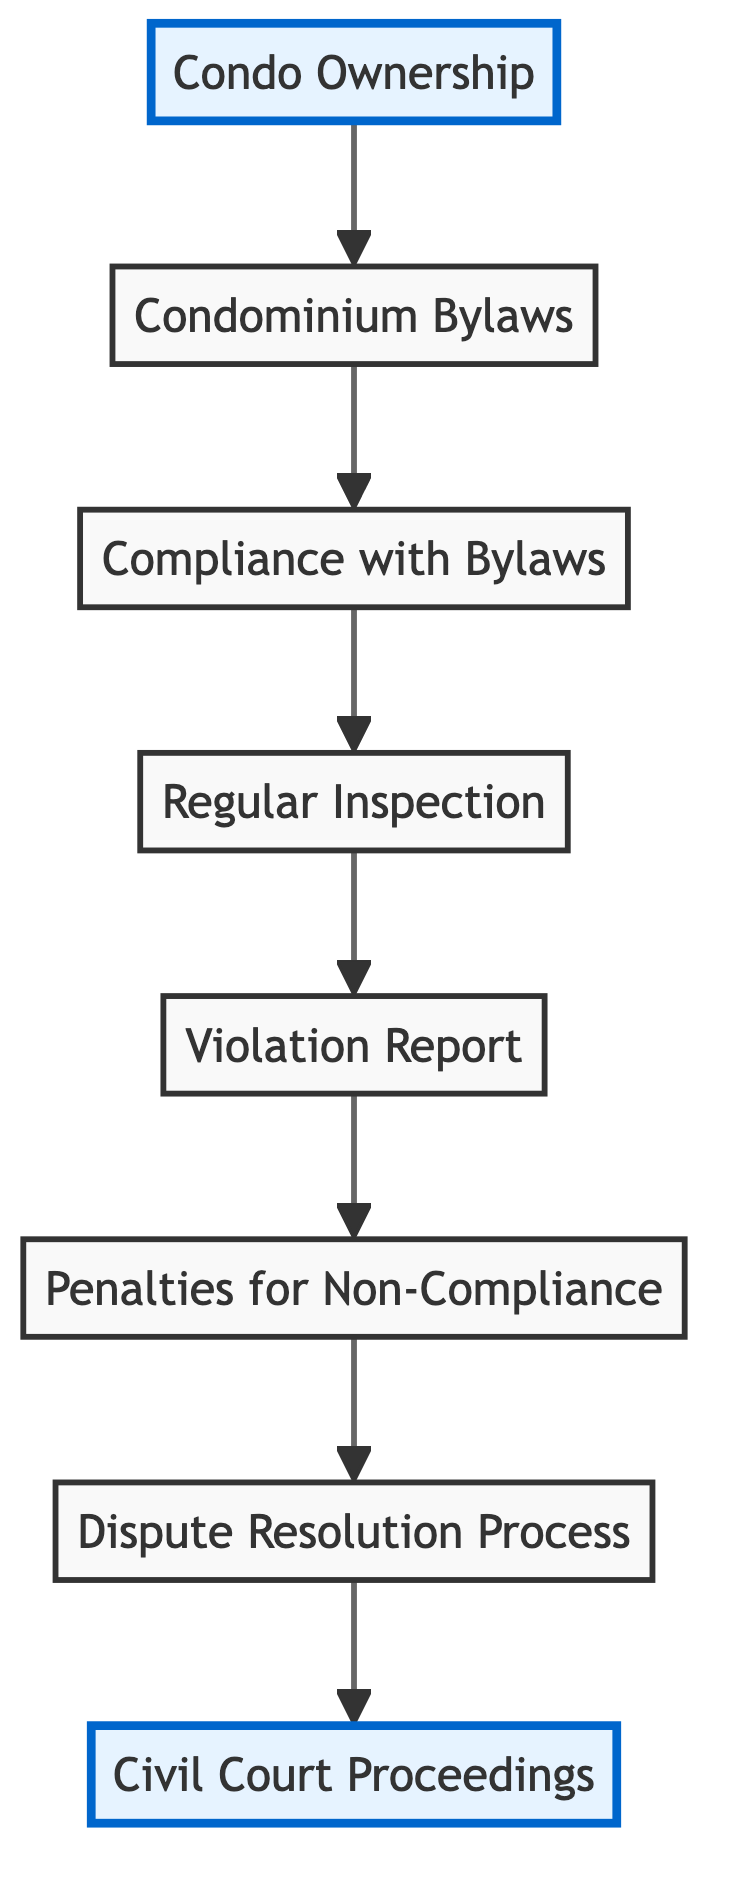What is the starting point of the responsibilities? The starting point of the responsibilities in the diagram is "Condo Ownership." This is the first node from which the flow of legal responsibilities begins.
Answer: Condo Ownership How many nodes are present in the diagram? The diagram contains 8 distinct nodes, which include "Condo Ownership," "Condominium Bylaws," "Compliance with Bylaws," "Regular Inspection," "Violation Report," "Penalties for Non-Compliance," "Dispute Resolution Process," and "Civil Court Proceedings." I counted each unique node in the visual representation.
Answer: 8 What follows after "Compliance with Bylaws"? After "Compliance with Bylaws," the next node is "Regular Inspection." This is determined by the directed edge that connects these two nodes in the diagram, indicating the flow of responsibilities.
Answer: Regular Inspection What is the outcome of a Violation Report? The outcome of a Violation Report leads to "Penalties for Non-Compliance." This is shown by the directed edge connecting the "Violation Report" node to the "Penalties" node.
Answer: Penalties for Non-Compliance Which node connects to "Court"? The node that connects to "Court" is "Dispute Resolution Process." The edge indicates that if disputes arise, they may lead to civil court proceedings. This is inferred from the flow direction in the diagram.
Answer: Dispute Resolution Process What is the total number of edges in the diagram? The diagram has 7 edges, which represent the connections between the nodes showing the path of responsibilities and processes leading to penalties and possible court proceedings. I counted the directed connections.
Answer: 7 What is the relationship between "Inspection" and "Violation Report"? The relationship is that "Inspection" leads to a "Violation Report." This is shown by the direct edge from "Inspection" to "Violation Report," indicating that inspections can result in reported violations.
Answer: Inspection leads to Violation Report What is the end point for non-compliance issues? The endpoint for non-compliance issues is "Civil Court Proceedings." This indicates that unresolved disputes or non-compliance can lead to court action, as shown by the final directed flow in the diagram.
Answer: Civil Court Proceedings 